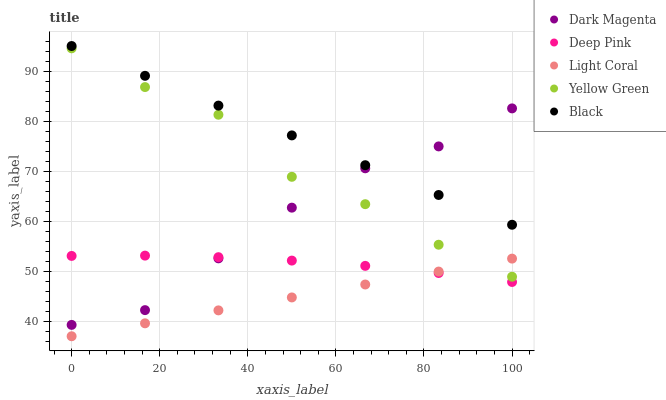Does Light Coral have the minimum area under the curve?
Answer yes or no. Yes. Does Black have the maximum area under the curve?
Answer yes or no. Yes. Does Deep Pink have the minimum area under the curve?
Answer yes or no. No. Does Deep Pink have the maximum area under the curve?
Answer yes or no. No. Is Light Coral the smoothest?
Answer yes or no. Yes. Is Yellow Green the roughest?
Answer yes or no. Yes. Is Deep Pink the smoothest?
Answer yes or no. No. Is Deep Pink the roughest?
Answer yes or no. No. Does Light Coral have the lowest value?
Answer yes or no. Yes. Does Deep Pink have the lowest value?
Answer yes or no. No. Does Black have the highest value?
Answer yes or no. Yes. Does Deep Pink have the highest value?
Answer yes or no. No. Is Deep Pink less than Black?
Answer yes or no. Yes. Is Yellow Green greater than Deep Pink?
Answer yes or no. Yes. Does Yellow Green intersect Light Coral?
Answer yes or no. Yes. Is Yellow Green less than Light Coral?
Answer yes or no. No. Is Yellow Green greater than Light Coral?
Answer yes or no. No. Does Deep Pink intersect Black?
Answer yes or no. No. 